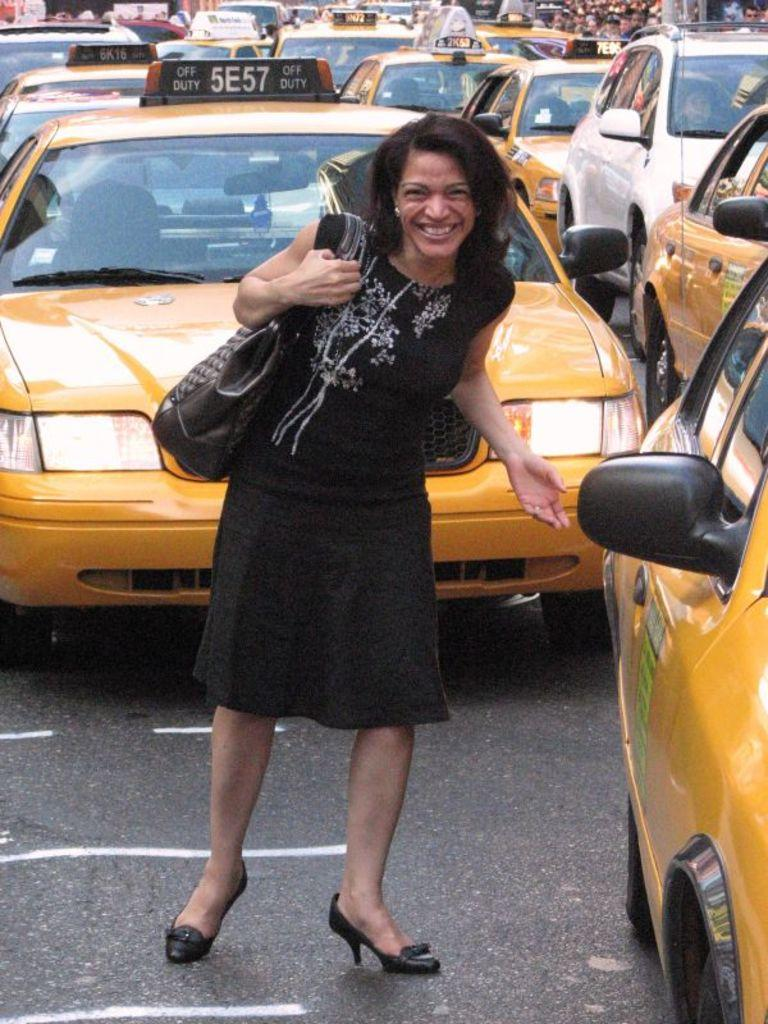<image>
Relay a brief, clear account of the picture shown. The taxi behind the woman has 5E57 on the sign at the top. 